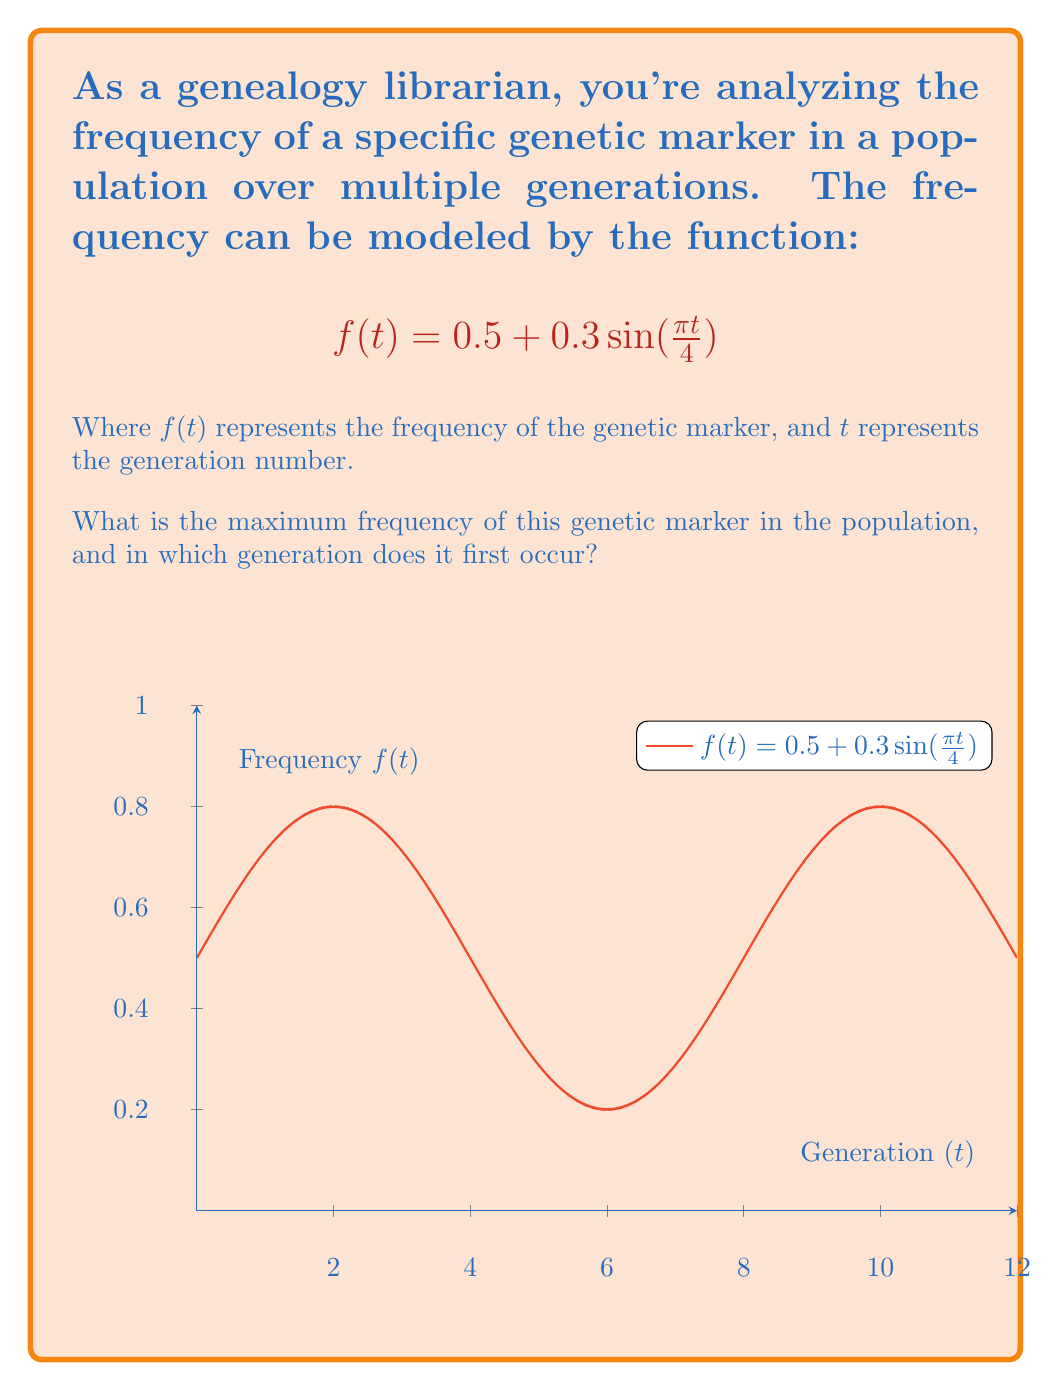What is the answer to this math problem? To solve this problem, we need to follow these steps:

1) The maximum value of a sine function occurs when its argument is $\frac{\pi}{2}$ (or 90 degrees). So, we need to find when $\frac{\pi t}{4} = \frac{\pi}{2}$.

2) Solving this equation:
   $$\frac{\pi t}{4} = \frac{\pi}{2}$$
   $$t = 2$$

3) This means the first maximum occurs at $t = 2$ (the 2nd generation).

4) To find the maximum frequency, we substitute $t = 2$ into our original function:

   $$f(2) = 0.5 + 0.3\sin(\frac{\pi \cdot 2}{4})$$
   $$= 0.5 + 0.3\sin(\frac{\pi}{2})$$
   $$= 0.5 + 0.3 \cdot 1$$
   $$= 0.5 + 0.3 = 0.8$$

5) Therefore, the maximum frequency is 0.8 or 80%.

6) This maximum will repeat every 8 generations due to the periodic nature of the sine function.
Answer: Maximum frequency: 0.8; First occurrence: 2nd generation 